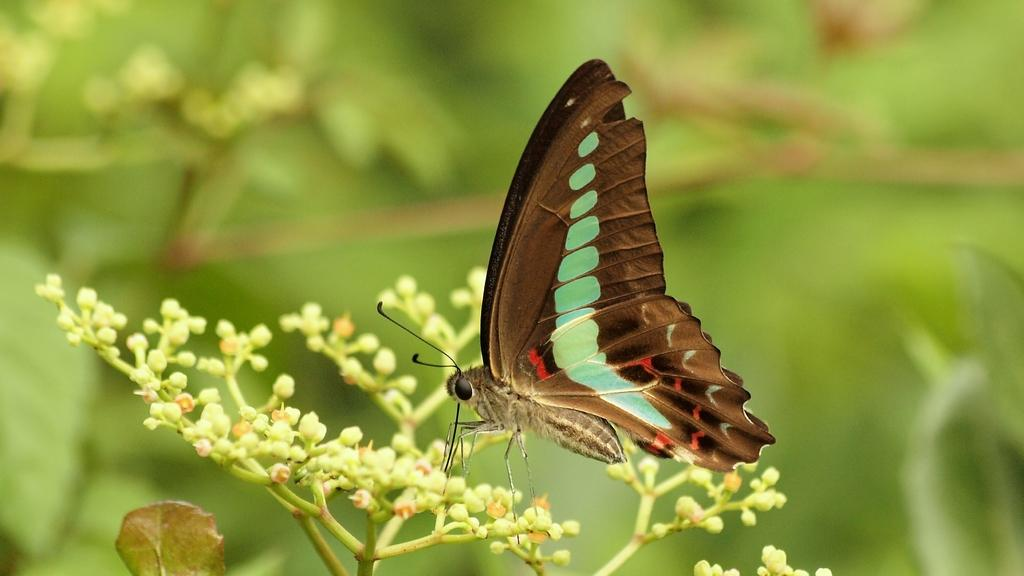What is the main subject of the image? There is a butterfly in the image. Where is the butterfly located? The butterfly is on a plant. How many cars are parked near the butterfly in the image? There are no cars present in the image; it features a butterfly on a plant. Is there a camp visible in the background of the image? There is no camp visible in the image; it features a butterfly on a plant. 